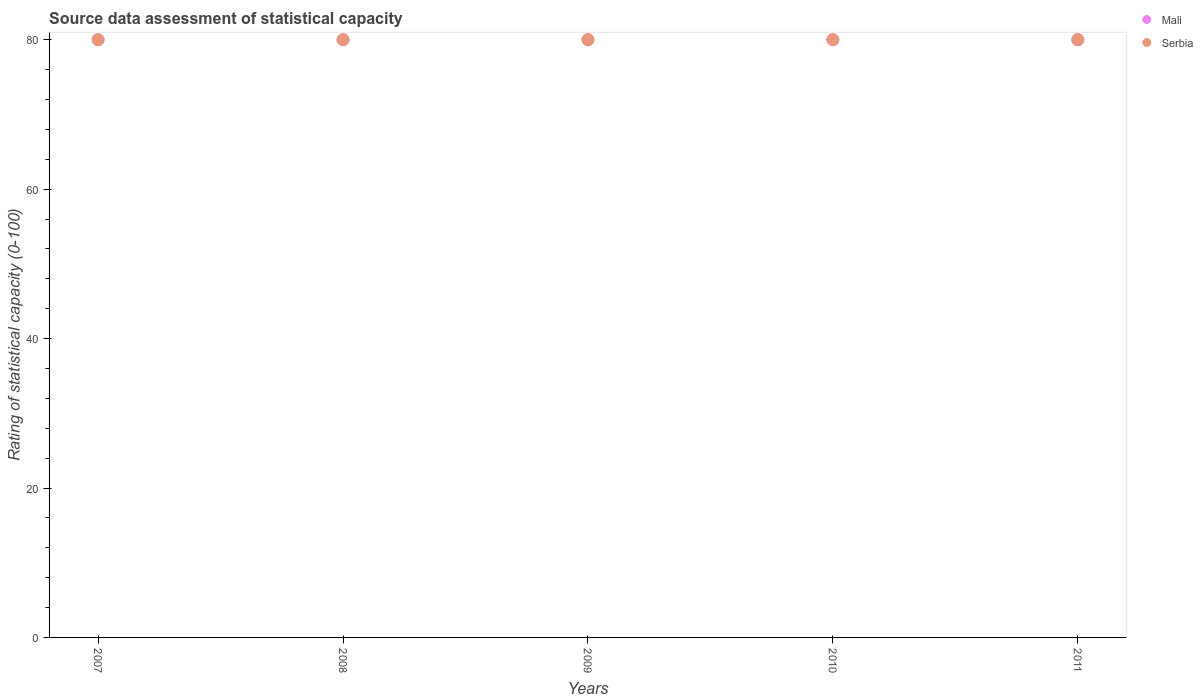How many different coloured dotlines are there?
Provide a short and direct response. 2. Is the number of dotlines equal to the number of legend labels?
Give a very brief answer. Yes. What is the rating of statistical capacity in Serbia in 2009?
Ensure brevity in your answer.  80. Across all years, what is the maximum rating of statistical capacity in Mali?
Keep it short and to the point. 80. Across all years, what is the minimum rating of statistical capacity in Mali?
Ensure brevity in your answer.  80. In which year was the rating of statistical capacity in Serbia maximum?
Provide a short and direct response. 2007. In which year was the rating of statistical capacity in Mali minimum?
Make the answer very short. 2007. What is the total rating of statistical capacity in Mali in the graph?
Give a very brief answer. 400. What is the difference between the rating of statistical capacity in Mali in 2008 and that in 2009?
Your answer should be very brief. 0. What is the ratio of the rating of statistical capacity in Mali in 2010 to that in 2011?
Make the answer very short. 1. Is the rating of statistical capacity in Mali in 2008 less than that in 2010?
Your response must be concise. No. What is the difference between the highest and the lowest rating of statistical capacity in Mali?
Your answer should be very brief. 0. Is the sum of the rating of statistical capacity in Mali in 2008 and 2011 greater than the maximum rating of statistical capacity in Serbia across all years?
Make the answer very short. Yes. Is the rating of statistical capacity in Serbia strictly greater than the rating of statistical capacity in Mali over the years?
Your answer should be very brief. No. Is the rating of statistical capacity in Serbia strictly less than the rating of statistical capacity in Mali over the years?
Offer a very short reply. No. How many years are there in the graph?
Ensure brevity in your answer.  5. Does the graph contain any zero values?
Ensure brevity in your answer.  No. Where does the legend appear in the graph?
Offer a terse response. Top right. How are the legend labels stacked?
Your answer should be compact. Vertical. What is the title of the graph?
Ensure brevity in your answer.  Source data assessment of statistical capacity. Does "Gambia, The" appear as one of the legend labels in the graph?
Your answer should be very brief. No. What is the label or title of the Y-axis?
Give a very brief answer. Rating of statistical capacity (0-100). What is the Rating of statistical capacity (0-100) of Serbia in 2007?
Offer a terse response. 80. What is the Rating of statistical capacity (0-100) in Serbia in 2008?
Provide a succinct answer. 80. What is the Rating of statistical capacity (0-100) of Mali in 2009?
Provide a succinct answer. 80. What is the Rating of statistical capacity (0-100) in Mali in 2011?
Your answer should be compact. 80. What is the Rating of statistical capacity (0-100) in Serbia in 2011?
Offer a very short reply. 80. Across all years, what is the maximum Rating of statistical capacity (0-100) of Mali?
Your response must be concise. 80. Across all years, what is the minimum Rating of statistical capacity (0-100) in Mali?
Make the answer very short. 80. What is the total Rating of statistical capacity (0-100) of Mali in the graph?
Make the answer very short. 400. What is the difference between the Rating of statistical capacity (0-100) of Mali in 2007 and that in 2008?
Your response must be concise. 0. What is the difference between the Rating of statistical capacity (0-100) in Serbia in 2007 and that in 2008?
Provide a succinct answer. 0. What is the difference between the Rating of statistical capacity (0-100) in Mali in 2007 and that in 2010?
Offer a terse response. 0. What is the difference between the Rating of statistical capacity (0-100) of Mali in 2007 and that in 2011?
Keep it short and to the point. 0. What is the difference between the Rating of statistical capacity (0-100) in Serbia in 2007 and that in 2011?
Make the answer very short. 0. What is the difference between the Rating of statistical capacity (0-100) in Mali in 2008 and that in 2009?
Your answer should be compact. 0. What is the difference between the Rating of statistical capacity (0-100) in Serbia in 2009 and that in 2010?
Offer a terse response. 0. What is the difference between the Rating of statistical capacity (0-100) of Mali in 2009 and that in 2011?
Offer a very short reply. 0. What is the difference between the Rating of statistical capacity (0-100) in Mali in 2010 and that in 2011?
Your response must be concise. 0. What is the difference between the Rating of statistical capacity (0-100) in Mali in 2007 and the Rating of statistical capacity (0-100) in Serbia in 2008?
Give a very brief answer. 0. What is the difference between the Rating of statistical capacity (0-100) of Mali in 2008 and the Rating of statistical capacity (0-100) of Serbia in 2010?
Offer a very short reply. 0. What is the difference between the Rating of statistical capacity (0-100) of Mali in 2009 and the Rating of statistical capacity (0-100) of Serbia in 2010?
Ensure brevity in your answer.  0. What is the difference between the Rating of statistical capacity (0-100) of Mali in 2009 and the Rating of statistical capacity (0-100) of Serbia in 2011?
Keep it short and to the point. 0. What is the difference between the Rating of statistical capacity (0-100) of Mali in 2010 and the Rating of statistical capacity (0-100) of Serbia in 2011?
Give a very brief answer. 0. What is the average Rating of statistical capacity (0-100) of Mali per year?
Provide a short and direct response. 80. What is the average Rating of statistical capacity (0-100) in Serbia per year?
Keep it short and to the point. 80. In the year 2007, what is the difference between the Rating of statistical capacity (0-100) of Mali and Rating of statistical capacity (0-100) of Serbia?
Offer a very short reply. 0. What is the ratio of the Rating of statistical capacity (0-100) of Mali in 2007 to that in 2008?
Your answer should be compact. 1. What is the ratio of the Rating of statistical capacity (0-100) in Serbia in 2007 to that in 2008?
Your answer should be very brief. 1. What is the ratio of the Rating of statistical capacity (0-100) in Mali in 2007 to that in 2009?
Provide a short and direct response. 1. What is the ratio of the Rating of statistical capacity (0-100) in Serbia in 2007 to that in 2009?
Give a very brief answer. 1. What is the ratio of the Rating of statistical capacity (0-100) of Mali in 2007 to that in 2010?
Give a very brief answer. 1. What is the ratio of the Rating of statistical capacity (0-100) in Serbia in 2007 to that in 2010?
Your answer should be compact. 1. What is the ratio of the Rating of statistical capacity (0-100) in Mali in 2007 to that in 2011?
Keep it short and to the point. 1. What is the ratio of the Rating of statistical capacity (0-100) in Serbia in 2007 to that in 2011?
Your response must be concise. 1. What is the ratio of the Rating of statistical capacity (0-100) in Mali in 2008 to that in 2009?
Offer a very short reply. 1. What is the ratio of the Rating of statistical capacity (0-100) in Serbia in 2008 to that in 2009?
Your answer should be compact. 1. What is the ratio of the Rating of statistical capacity (0-100) in Mali in 2008 to that in 2011?
Give a very brief answer. 1. What is the ratio of the Rating of statistical capacity (0-100) in Mali in 2009 to that in 2010?
Provide a succinct answer. 1. What is the ratio of the Rating of statistical capacity (0-100) in Mali in 2010 to that in 2011?
Your response must be concise. 1. What is the ratio of the Rating of statistical capacity (0-100) in Serbia in 2010 to that in 2011?
Keep it short and to the point. 1. What is the difference between the highest and the lowest Rating of statistical capacity (0-100) in Mali?
Offer a very short reply. 0. 